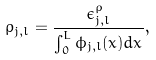Convert formula to latex. <formula><loc_0><loc_0><loc_500><loc_500>\rho _ { j , l } = \frac { \epsilon ^ { \rho } _ { j , l } } { \int _ { 0 } ^ { L } \phi _ { j , l } ( x ) d x } ,</formula> 